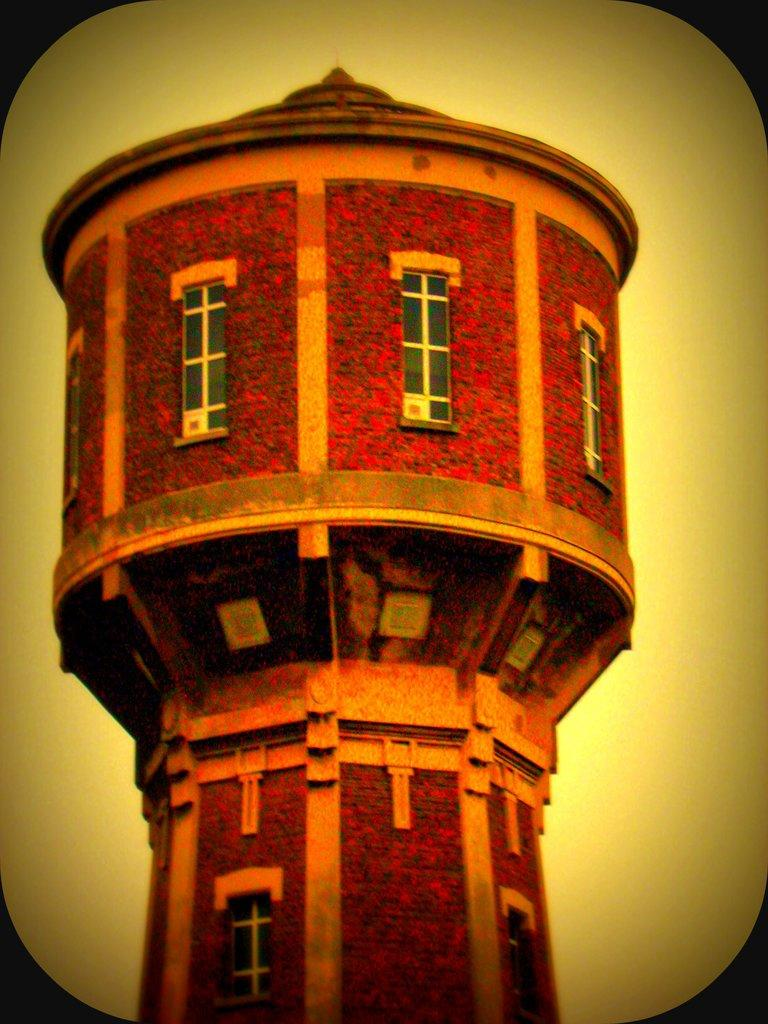What is the main subject in the center of the image? There is a building tower in the center of the image. Is there a spy hiding behind the building tower in the image? There is no indication of a spy or any hidden figures in the image; it only features a building tower. 